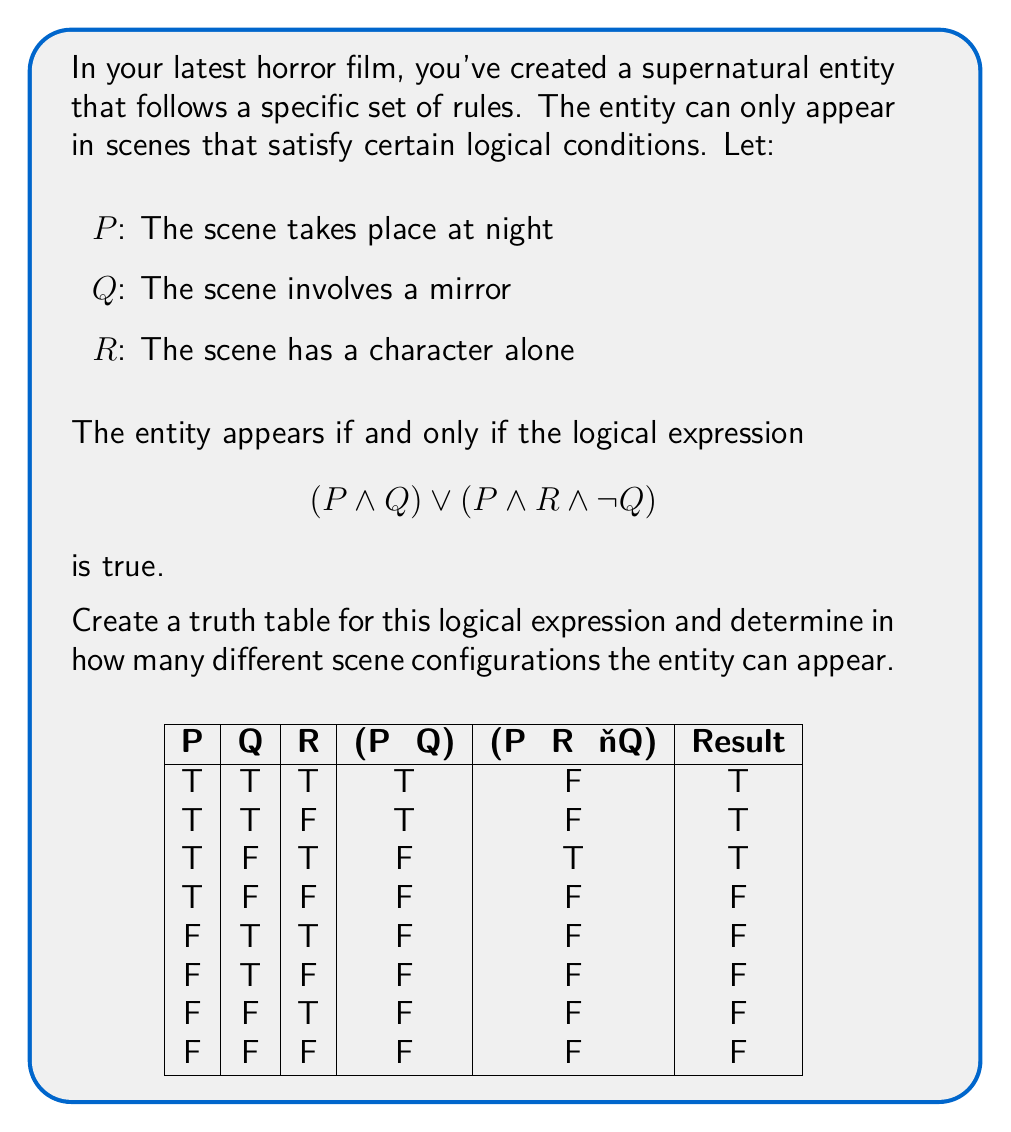Could you help me with this problem? Let's approach this step-by-step:

1) First, we need to understand the logical expression:
   $$(P \land Q) \lor (P \land R \land \neg Q)$$
   This means the entity appears if either:
   - It's night (P) AND there's a mirror (Q), OR
   - It's night (P) AND a character is alone (R) AND there's no mirror (¬Q)

2) We create a truth table with columns for P, Q, R, (P ∧ Q), (P ∧ R ∧ ¬Q), and the final result.

3) We evaluate each row:
   
   Row 1 (T,T,T): (T ∧ T) ∨ (T ∧ T ∧ F) = T ∨ F = T
   Row 2 (T,T,F): (T ∧ T) ∨ (T ∧ F ∧ F) = T ∨ F = T
   Row 3 (T,F,T): (T ∧ F) ∨ (T ∧ T ∧ T) = F ∨ T = T
   Row 4 (T,F,F): (T ∧ F) ∨ (T ∧ F ∧ T) = F ∨ F = F
   Row 5 (F,T,T): (F ∧ T) ∨ (F ∧ T ∧ F) = F ∨ F = F
   Row 6 (F,T,F): (F ∧ T) ∨ (F ∧ F ∧ F) = F ∨ F = F
   Row 7 (F,F,T): (F ∧ F) ∨ (F ∧ T ∧ T) = F ∨ F = F
   Row 8 (F,F,F): (F ∧ F) ∨ (F ∧ F ∧ T) = F ∨ F = F

4) Counting the number of True results in the final column gives us the number of scene configurations where the entity can appear.

5) We can see that there are 3 True results in the final column.
Answer: 3 